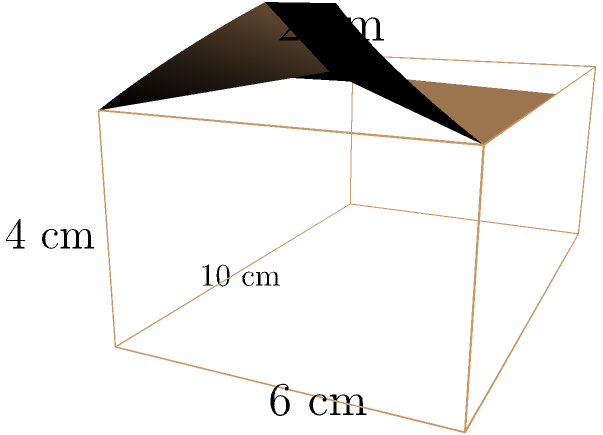You have a vintage radio cabinet with a rectangular base and a curved top, as shown in the diagram. The base measures 10 cm long, 6 cm wide, and 4 cm high. The curved top adds an additional 2 cm to the height at the center. Assuming the curved top is a perfect cylindrical section, calculate the total surface area of the radio cabinet in square centimeters. Let's break this down step-by-step:

1) First, calculate the surface area of the rectangular base:
   - Bottom: $10 \times 6 = 60$ cm²
   - Front and back: $2 \times (10 \times 4) = 80$ cm²
   - Sides: $2 \times (6 \times 4) = 48$ cm²
   Total for rectangular part: $60 + 80 + 48 = 188$ cm²

2) Now, for the curved top:
   - We need to find the radius of the cylinder section. Let $r$ be the radius.
   - The width of the cabinet is the chord of the circular section: $6^2 = 4r^2 - (r-2)^2$
   - Solving this: $r = 5$ cm

3) The arc length of the curved top:
   - Central angle: $\theta = 2 \arcsin(\frac{6}{10}) = 2.2839$ radians
   - Arc length: $L = r\theta = 5 \times 2.2839 = 11.4195$ cm

4) Surface area of the curved top:
   - $11.4195 \times 10 = 114.195$ cm²

5) Total surface area:
   $188 + 114.195 = 302.195$ cm²
Answer: 302.195 cm² 